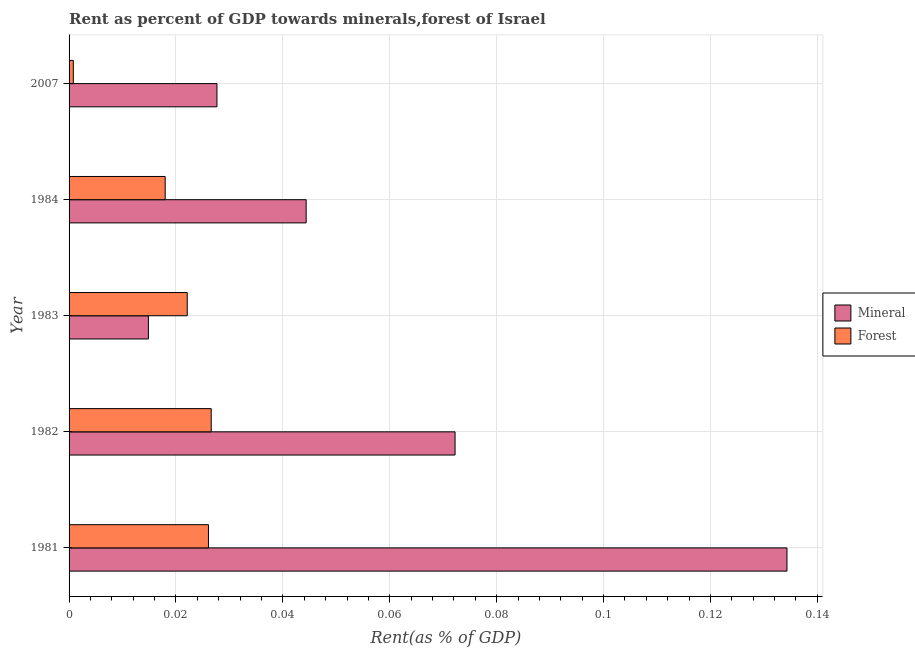How many different coloured bars are there?
Make the answer very short. 2. Are the number of bars per tick equal to the number of legend labels?
Your answer should be very brief. Yes. Are the number of bars on each tick of the Y-axis equal?
Your response must be concise. Yes. How many bars are there on the 5th tick from the top?
Offer a terse response. 2. What is the forest rent in 1981?
Keep it short and to the point. 0.03. Across all years, what is the maximum mineral rent?
Make the answer very short. 0.13. Across all years, what is the minimum mineral rent?
Your response must be concise. 0.01. What is the total forest rent in the graph?
Keep it short and to the point. 0.09. What is the difference between the forest rent in 1983 and that in 1984?
Make the answer very short. 0. What is the difference between the mineral rent in 1984 and the forest rent in 1981?
Give a very brief answer. 0.02. What is the average forest rent per year?
Ensure brevity in your answer.  0.02. In the year 1981, what is the difference between the forest rent and mineral rent?
Make the answer very short. -0.11. In how many years, is the forest rent greater than 0.012 %?
Provide a succinct answer. 4. What is the ratio of the mineral rent in 1981 to that in 1982?
Your answer should be very brief. 1.86. Is the difference between the forest rent in 1983 and 2007 greater than the difference between the mineral rent in 1983 and 2007?
Offer a very short reply. Yes. What is the difference between the highest and the lowest mineral rent?
Your answer should be compact. 0.12. What does the 1st bar from the top in 2007 represents?
Give a very brief answer. Forest. What does the 1st bar from the bottom in 1983 represents?
Give a very brief answer. Mineral. How many bars are there?
Your answer should be compact. 10. Are all the bars in the graph horizontal?
Offer a very short reply. Yes. Does the graph contain any zero values?
Provide a short and direct response. No. How are the legend labels stacked?
Your response must be concise. Vertical. What is the title of the graph?
Keep it short and to the point. Rent as percent of GDP towards minerals,forest of Israel. Does "Diesel" appear as one of the legend labels in the graph?
Offer a very short reply. No. What is the label or title of the X-axis?
Your answer should be very brief. Rent(as % of GDP). What is the label or title of the Y-axis?
Keep it short and to the point. Year. What is the Rent(as % of GDP) in Mineral in 1981?
Offer a very short reply. 0.13. What is the Rent(as % of GDP) in Forest in 1981?
Provide a short and direct response. 0.03. What is the Rent(as % of GDP) of Mineral in 1982?
Ensure brevity in your answer.  0.07. What is the Rent(as % of GDP) in Forest in 1982?
Provide a succinct answer. 0.03. What is the Rent(as % of GDP) of Mineral in 1983?
Your response must be concise. 0.01. What is the Rent(as % of GDP) of Forest in 1983?
Make the answer very short. 0.02. What is the Rent(as % of GDP) of Mineral in 1984?
Your response must be concise. 0.04. What is the Rent(as % of GDP) of Forest in 1984?
Offer a terse response. 0.02. What is the Rent(as % of GDP) of Mineral in 2007?
Provide a succinct answer. 0.03. What is the Rent(as % of GDP) in Forest in 2007?
Keep it short and to the point. 0. Across all years, what is the maximum Rent(as % of GDP) of Mineral?
Ensure brevity in your answer.  0.13. Across all years, what is the maximum Rent(as % of GDP) of Forest?
Your answer should be compact. 0.03. Across all years, what is the minimum Rent(as % of GDP) of Mineral?
Keep it short and to the point. 0.01. Across all years, what is the minimum Rent(as % of GDP) of Forest?
Give a very brief answer. 0. What is the total Rent(as % of GDP) in Mineral in the graph?
Keep it short and to the point. 0.29. What is the total Rent(as % of GDP) of Forest in the graph?
Offer a terse response. 0.09. What is the difference between the Rent(as % of GDP) in Mineral in 1981 and that in 1982?
Your response must be concise. 0.06. What is the difference between the Rent(as % of GDP) in Forest in 1981 and that in 1982?
Provide a short and direct response. -0. What is the difference between the Rent(as % of GDP) of Mineral in 1981 and that in 1983?
Keep it short and to the point. 0.12. What is the difference between the Rent(as % of GDP) in Forest in 1981 and that in 1983?
Offer a terse response. 0. What is the difference between the Rent(as % of GDP) of Mineral in 1981 and that in 1984?
Your answer should be compact. 0.09. What is the difference between the Rent(as % of GDP) in Forest in 1981 and that in 1984?
Provide a short and direct response. 0.01. What is the difference between the Rent(as % of GDP) in Mineral in 1981 and that in 2007?
Provide a succinct answer. 0.11. What is the difference between the Rent(as % of GDP) of Forest in 1981 and that in 2007?
Your answer should be compact. 0.03. What is the difference between the Rent(as % of GDP) in Mineral in 1982 and that in 1983?
Offer a very short reply. 0.06. What is the difference between the Rent(as % of GDP) in Forest in 1982 and that in 1983?
Your answer should be compact. 0. What is the difference between the Rent(as % of GDP) in Mineral in 1982 and that in 1984?
Make the answer very short. 0.03. What is the difference between the Rent(as % of GDP) in Forest in 1982 and that in 1984?
Give a very brief answer. 0.01. What is the difference between the Rent(as % of GDP) in Mineral in 1982 and that in 2007?
Your response must be concise. 0.04. What is the difference between the Rent(as % of GDP) of Forest in 1982 and that in 2007?
Give a very brief answer. 0.03. What is the difference between the Rent(as % of GDP) in Mineral in 1983 and that in 1984?
Keep it short and to the point. -0.03. What is the difference between the Rent(as % of GDP) in Forest in 1983 and that in 1984?
Your response must be concise. 0. What is the difference between the Rent(as % of GDP) of Mineral in 1983 and that in 2007?
Keep it short and to the point. -0.01. What is the difference between the Rent(as % of GDP) of Forest in 1983 and that in 2007?
Your answer should be very brief. 0.02. What is the difference between the Rent(as % of GDP) of Mineral in 1984 and that in 2007?
Provide a short and direct response. 0.02. What is the difference between the Rent(as % of GDP) in Forest in 1984 and that in 2007?
Make the answer very short. 0.02. What is the difference between the Rent(as % of GDP) of Mineral in 1981 and the Rent(as % of GDP) of Forest in 1982?
Provide a short and direct response. 0.11. What is the difference between the Rent(as % of GDP) of Mineral in 1981 and the Rent(as % of GDP) of Forest in 1983?
Keep it short and to the point. 0.11. What is the difference between the Rent(as % of GDP) of Mineral in 1981 and the Rent(as % of GDP) of Forest in 1984?
Offer a very short reply. 0.12. What is the difference between the Rent(as % of GDP) in Mineral in 1981 and the Rent(as % of GDP) in Forest in 2007?
Your response must be concise. 0.13. What is the difference between the Rent(as % of GDP) in Mineral in 1982 and the Rent(as % of GDP) in Forest in 1983?
Offer a terse response. 0.05. What is the difference between the Rent(as % of GDP) of Mineral in 1982 and the Rent(as % of GDP) of Forest in 1984?
Offer a terse response. 0.05. What is the difference between the Rent(as % of GDP) of Mineral in 1982 and the Rent(as % of GDP) of Forest in 2007?
Your response must be concise. 0.07. What is the difference between the Rent(as % of GDP) in Mineral in 1983 and the Rent(as % of GDP) in Forest in 1984?
Your answer should be very brief. -0. What is the difference between the Rent(as % of GDP) of Mineral in 1983 and the Rent(as % of GDP) of Forest in 2007?
Your answer should be compact. 0.01. What is the difference between the Rent(as % of GDP) in Mineral in 1984 and the Rent(as % of GDP) in Forest in 2007?
Make the answer very short. 0.04. What is the average Rent(as % of GDP) of Mineral per year?
Offer a terse response. 0.06. What is the average Rent(as % of GDP) of Forest per year?
Your answer should be very brief. 0.02. In the year 1981, what is the difference between the Rent(as % of GDP) of Mineral and Rent(as % of GDP) of Forest?
Make the answer very short. 0.11. In the year 1982, what is the difference between the Rent(as % of GDP) of Mineral and Rent(as % of GDP) of Forest?
Your answer should be very brief. 0.05. In the year 1983, what is the difference between the Rent(as % of GDP) in Mineral and Rent(as % of GDP) in Forest?
Your response must be concise. -0.01. In the year 1984, what is the difference between the Rent(as % of GDP) in Mineral and Rent(as % of GDP) in Forest?
Offer a very short reply. 0.03. In the year 2007, what is the difference between the Rent(as % of GDP) in Mineral and Rent(as % of GDP) in Forest?
Keep it short and to the point. 0.03. What is the ratio of the Rent(as % of GDP) in Mineral in 1981 to that in 1982?
Keep it short and to the point. 1.86. What is the ratio of the Rent(as % of GDP) in Forest in 1981 to that in 1982?
Provide a succinct answer. 0.98. What is the ratio of the Rent(as % of GDP) of Mineral in 1981 to that in 1983?
Your answer should be very brief. 9.05. What is the ratio of the Rent(as % of GDP) of Forest in 1981 to that in 1983?
Ensure brevity in your answer.  1.18. What is the ratio of the Rent(as % of GDP) of Mineral in 1981 to that in 1984?
Make the answer very short. 3.03. What is the ratio of the Rent(as % of GDP) in Forest in 1981 to that in 1984?
Offer a terse response. 1.45. What is the ratio of the Rent(as % of GDP) in Mineral in 1981 to that in 2007?
Keep it short and to the point. 4.85. What is the ratio of the Rent(as % of GDP) in Forest in 1981 to that in 2007?
Ensure brevity in your answer.  32.86. What is the ratio of the Rent(as % of GDP) in Mineral in 1982 to that in 1983?
Provide a succinct answer. 4.87. What is the ratio of the Rent(as % of GDP) of Forest in 1982 to that in 1983?
Your answer should be compact. 1.2. What is the ratio of the Rent(as % of GDP) in Mineral in 1982 to that in 1984?
Give a very brief answer. 1.63. What is the ratio of the Rent(as % of GDP) of Forest in 1982 to that in 1984?
Your answer should be very brief. 1.48. What is the ratio of the Rent(as % of GDP) of Mineral in 1982 to that in 2007?
Make the answer very short. 2.61. What is the ratio of the Rent(as % of GDP) of Forest in 1982 to that in 2007?
Keep it short and to the point. 33.51. What is the ratio of the Rent(as % of GDP) of Mineral in 1983 to that in 1984?
Give a very brief answer. 0.33. What is the ratio of the Rent(as % of GDP) in Forest in 1983 to that in 1984?
Offer a terse response. 1.23. What is the ratio of the Rent(as % of GDP) in Mineral in 1983 to that in 2007?
Your response must be concise. 0.54. What is the ratio of the Rent(as % of GDP) of Forest in 1983 to that in 2007?
Give a very brief answer. 27.86. What is the ratio of the Rent(as % of GDP) in Mineral in 1984 to that in 2007?
Make the answer very short. 1.6. What is the ratio of the Rent(as % of GDP) of Forest in 1984 to that in 2007?
Your answer should be compact. 22.66. What is the difference between the highest and the second highest Rent(as % of GDP) of Mineral?
Provide a short and direct response. 0.06. What is the difference between the highest and the second highest Rent(as % of GDP) of Forest?
Keep it short and to the point. 0. What is the difference between the highest and the lowest Rent(as % of GDP) of Mineral?
Your answer should be very brief. 0.12. What is the difference between the highest and the lowest Rent(as % of GDP) of Forest?
Offer a terse response. 0.03. 